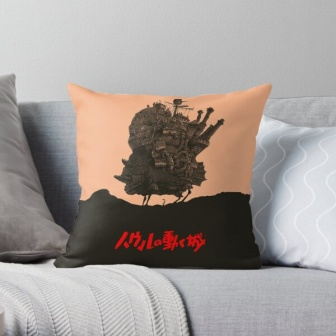If this pillow were a portal to another world, what would that world look like? If this pillow were a portal to another world, stepping through it would take you to a land of endless wonder and imagination. You'd find yourself in a lush meadow under a sky painted with shifting hues of pink and gold. In the distance, the castle from the pillow stands majestically atop a hill, its towers reaching towards the clouds, festooned with colorful banners. Surrounding the castle is a village bustling with fantastical creatures - from talking animals to mystical beings with wings and horns, all coexisting in harmony. The air is filled with the scent of blooming flowers and the sound of ethereal music that seems to come from nowhere and everywhere. Rivers of crystal-clear water wind through the landscape, and bridges made of woven vines connect different parts of the magical kingdom. Each step taken in this world reveals a new wonder, a new adventure, waiting to be explored, with the promise that the pillow portal can always bring you back home whenever you wish. 